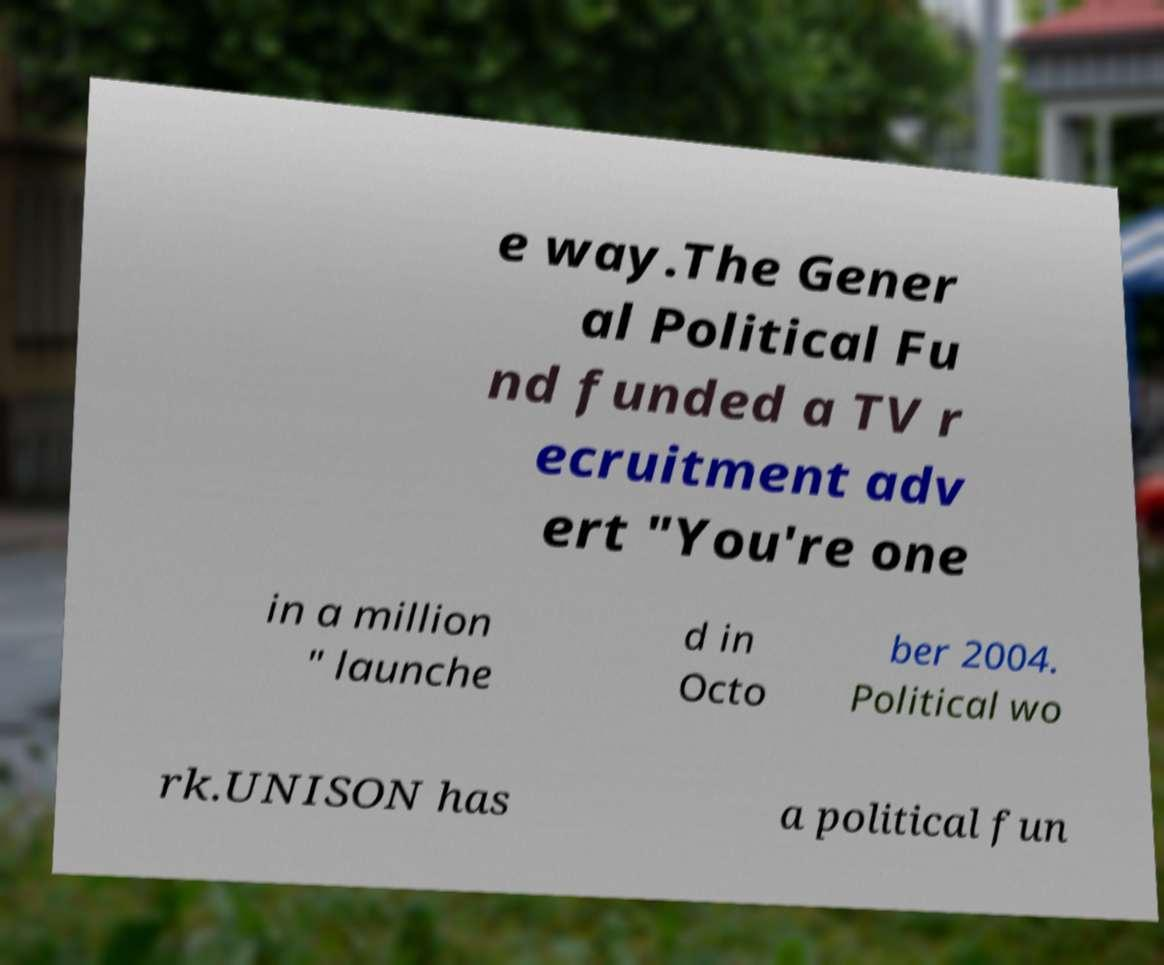Please read and relay the text visible in this image. What does it say? e way.The Gener al Political Fu nd funded a TV r ecruitment adv ert "You're one in a million " launche d in Octo ber 2004. Political wo rk.UNISON has a political fun 